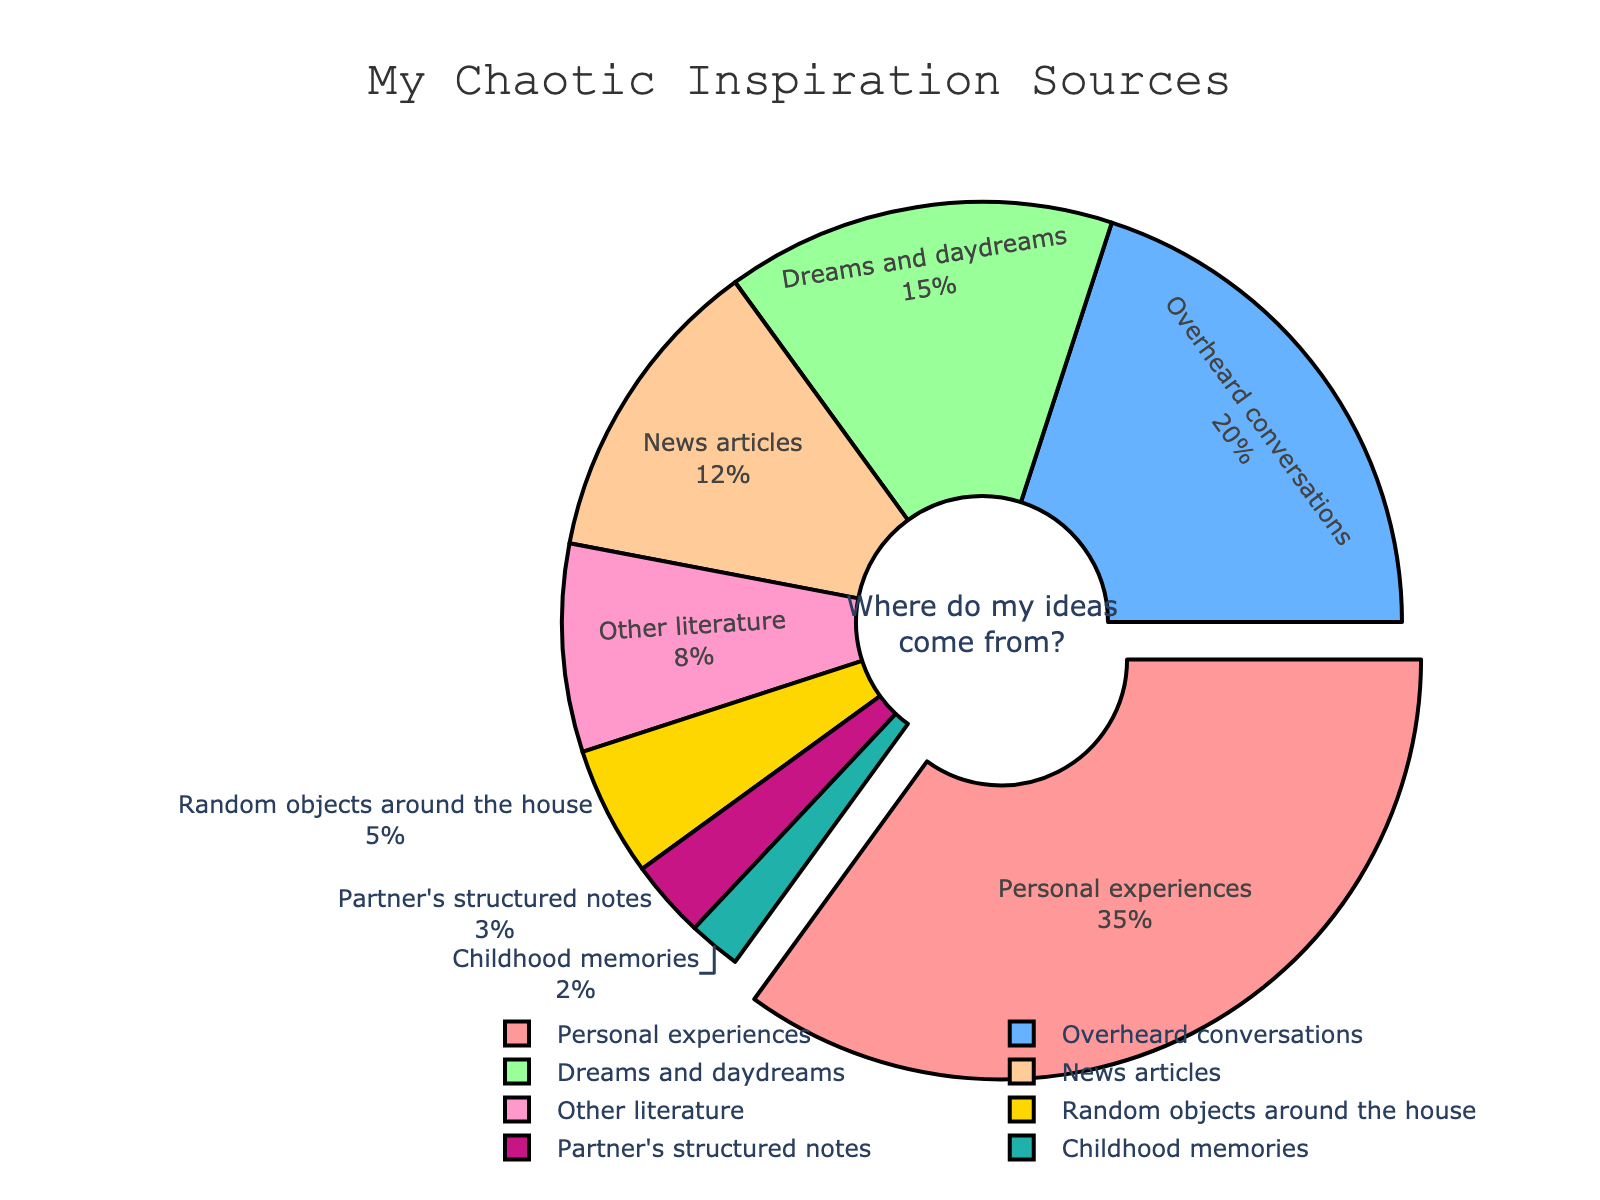How much more inspiration do you get from personal experiences compared to overheard conversations? To determine the difference, we subtract the percentage of overheard conversations from the percentage of personal experiences. From the figure, personal experiences are 35% and overheard conversations are 20%. Therefore, 35% - 20% = 15%.
Answer: 15% Which source provides the least inspiration? To find the inspiration source with the least percentage, we look for the smallest segment in the pie chart. According to the data, childhood memories provide 2%, which is the smallest.
Answer: Childhood memories What is the combined inspiration from news articles and other literature? To find the combined percentage, we add the percentages of news articles and other literature. From the figure, news articles account for 12% and other literature for 8%. Therefore, 12% + 8% = 20%.
Answer: 20% What fraction of your inspiration comes from dreams/daydreams and partner's structured notes combined? To find this fraction, we add the percentages and then convert the sum into a fraction. Dreams/daydreams account for 15% and partner's structured notes for 3%, making a total of 18%. As a fraction of the whole (100%), it is 18/100 or 0.18.
Answer: 0.18 Which source is indicated with a pull-out effect in the pie chart? The pull-out effect highlights the segment with the highest percentage. In this case, personal experiences, which account for 35%, is visually emphasized with a pull-out effect.
Answer: Personal experiences Is the inspiration from random objects around the house greater or less than the inspiration from dreams/daydreams? We compare the percentages for random objects (5%) and dreams/daydreams (15%). Since 5% is less than 15%, the inspiration from random objects around the house is less.
Answer: Less What percentage of inspiration comes from sources outside of your household? First, we list the sources: personal experiences, overheard conversations, partner's structured notes, and random objects around the house. Adding their percentages: 35% + 20% + 3% + 5% = 63%. The total percentage of external sources is 100% - 63% = 37%.
Answer: 37% How much more significant are your personal experiences as a source of inspiration compared to news articles? We find the difference by subtracting the percentage of news articles from that of personal experiences. Personal experiences are 35%, and news articles are 12%. Therefore, 35% - 12% = 23%.
Answer: 23% What combined percentage of inspiration comes from less prevalent sources (less than 10%)? Identify sources with percentages less than 10%: other literature (8%), random objects around the house (5%), partner's structured notes (3%), and childhood memories (2%). Adding these gives 8% + 5% + 3% + 2% = 18%.
Answer: 18% Which color represents the news articles segment in the pie chart? By referring to the color-code data and their sequence, the news articles segment is colored in a hue distinct from others. The specific color associated with news articles in the pie chart is light gold.
Answer: Light gold 